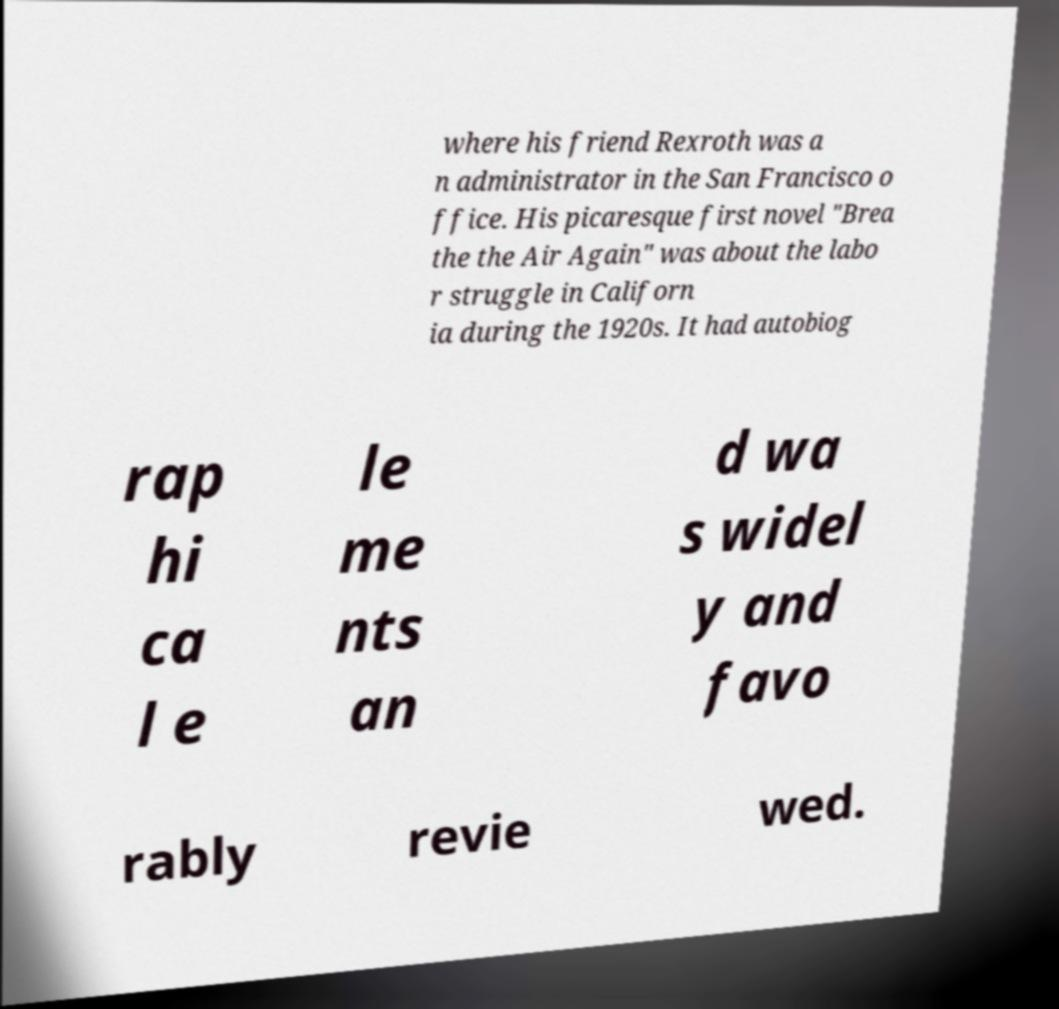Could you assist in decoding the text presented in this image and type it out clearly? where his friend Rexroth was a n administrator in the San Francisco o ffice. His picaresque first novel "Brea the the Air Again" was about the labo r struggle in Californ ia during the 1920s. It had autobiog rap hi ca l e le me nts an d wa s widel y and favo rably revie wed. 